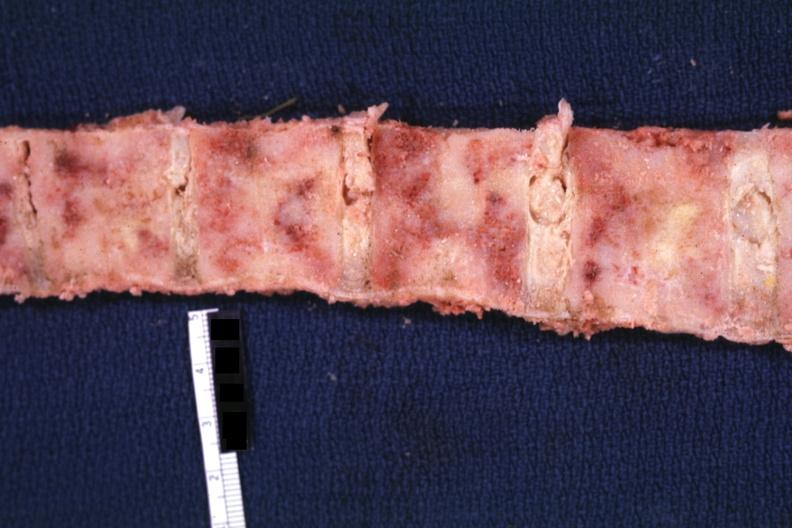how is marrow filled with tumor?
Answer the question using a single word or phrase. Obvious 